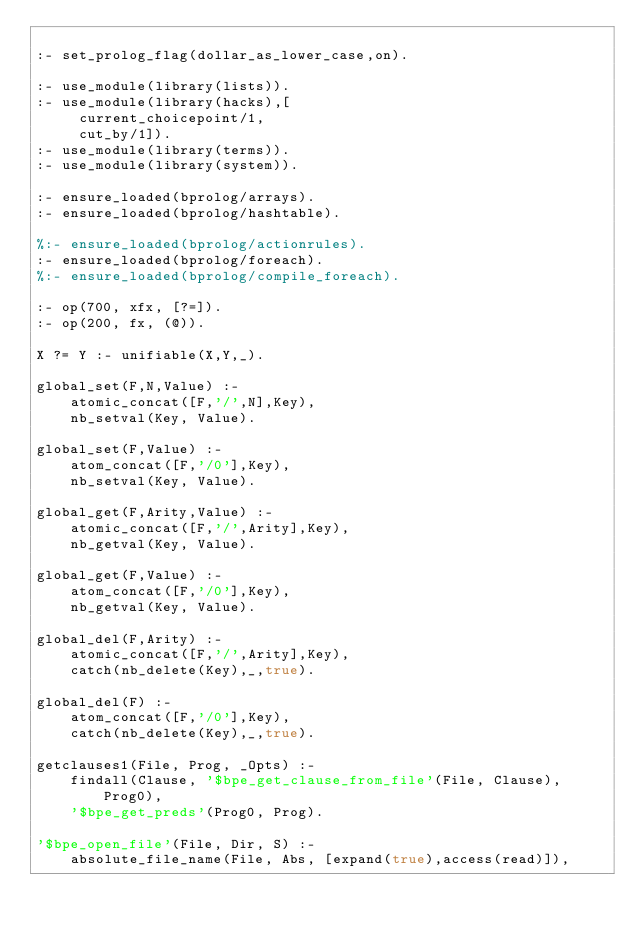Convert code to text. <code><loc_0><loc_0><loc_500><loc_500><_Prolog_>
:- set_prolog_flag(dollar_as_lower_case,on).

:- use_module(library(lists)).
:- use_module(library(hacks),[
     current_choicepoint/1,
     cut_by/1]).
:- use_module(library(terms)).
:- use_module(library(system)).

:- ensure_loaded(bprolog/arrays).
:- ensure_loaded(bprolog/hashtable).

%:- ensure_loaded(bprolog/actionrules).
:- ensure_loaded(bprolog/foreach).
%:- ensure_loaded(bprolog/compile_foreach).

:- op(700, xfx, [?=]).
:- op(200, fx, (@)).

X ?= Y :- unifiable(X,Y,_).

global_set(F,N,Value) :-
	atomic_concat([F,'/',N],Key),
	nb_setval(Key, Value).

global_set(F,Value) :-
	atom_concat([F,'/0'],Key),
	nb_setval(Key, Value).

global_get(F,Arity,Value) :-
	atomic_concat([F,'/',Arity],Key),
	nb_getval(Key, Value).

global_get(F,Value) :-
	atom_concat([F,'/0'],Key),
	nb_getval(Key, Value).

global_del(F,Arity) :-
	atomic_concat([F,'/',Arity],Key),
	catch(nb_delete(Key),_,true).

global_del(F) :-
	atom_concat([F,'/0'],Key),
	catch(nb_delete(Key),_,true).

getclauses1(File, Prog, _Opts) :-
	findall(Clause, '$bpe_get_clause_from_file'(File, Clause), Prog0),
	'$bpe_get_preds'(Prog0, Prog).

'$bpe_open_file'(File, Dir, S) :-
	absolute_file_name(File, Abs, [expand(true),access(read)]),</code> 